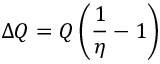Convert formula to latex. <formula><loc_0><loc_0><loc_500><loc_500>\Delta Q = Q \left ( { \frac { 1 } { \eta } } - 1 \right )</formula> 